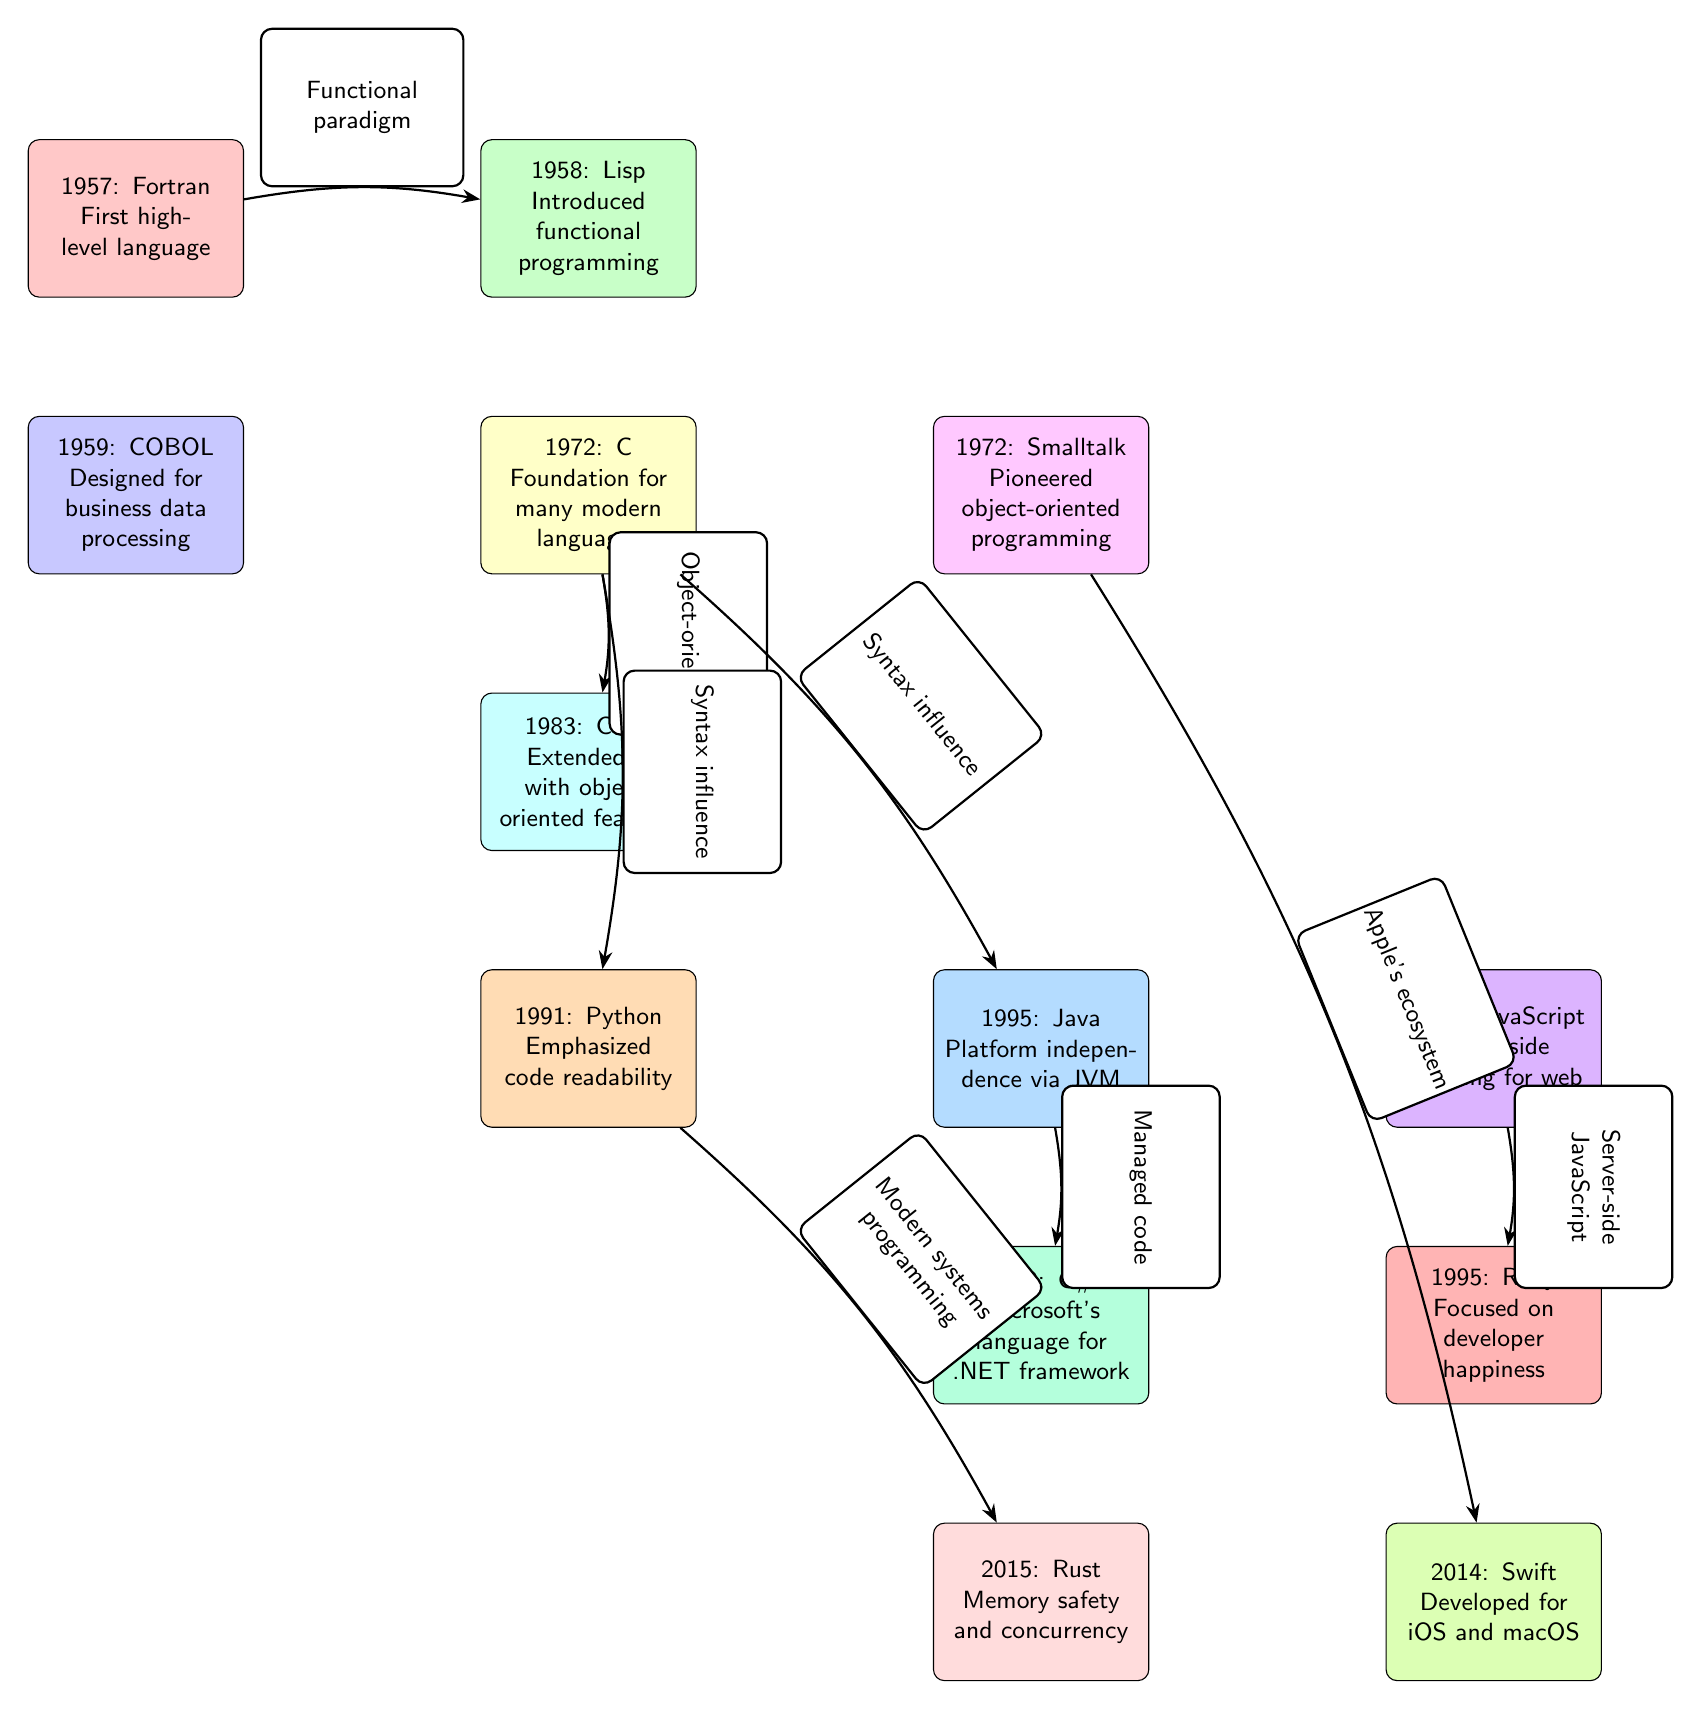What year was Fortran introduced? Fortran is listed at the top of the diagram with the label "1957: Fortran," which clearly shows the year of its introduction.
Answer: 1957 What programming paradigm did Lisp introduce? The diagram states that Lisp "Introduced functional programming," marking it as the language that brought this concept into programming.
Answer: Functional programming Which language is designed for business data processing? The diagram indicates that COBOL is labeled "Designed for business data processing" and is positioned directly below Fortran, confirming its purpose.
Answer: COBOL How many languages in the diagram were introduced in 1995? By counting the nodes labeled "1995" in the diagram, we find "Java," "JavaScript," and "Ruby," totaling three languages.
Answer: 3 Which language did Python influence directly? The edge labeled "Modern systems programming" connects Python to Rust, indicating that Rust is directly influenced by Python according to the diagram's representation.
Answer: Rust What is the relationship between C++ and C in the diagram? The diagram shows an edge from C to CPP with the label "Object-oriented," indicating that C++ extends C with object-oriented features.
Answer: Object-oriented In what way did Java influence C#? The diagram shows an edge labeled "Managed code" from Java to C#, demonstrating that the C# programming language was influenced by Java's managed code approach.
Answer: Managed code Which language was developed for Apple's ecosystem? The diagram indicates an influence line going from Smalltalk to Swift with the label "Apple's ecosystem," designating Swift's development context.
Answer: Swift How many key milestones are represented in the diagram? By counting all the nodes shown in the diagram, we identify a total of twelve different programming languages or milestones represented.
Answer: 12 